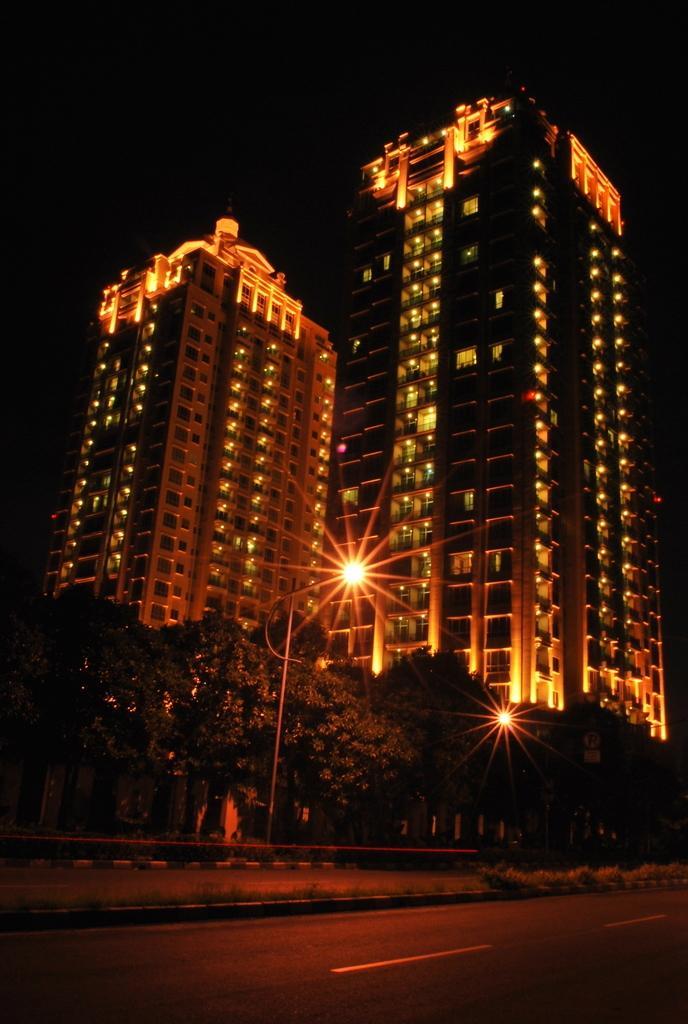In one or two sentences, can you explain what this image depicts? In the center of the image we can see buildings, lights, pole, trees are there. At the bottom of the image road is there. At the top of the image sky is there. 